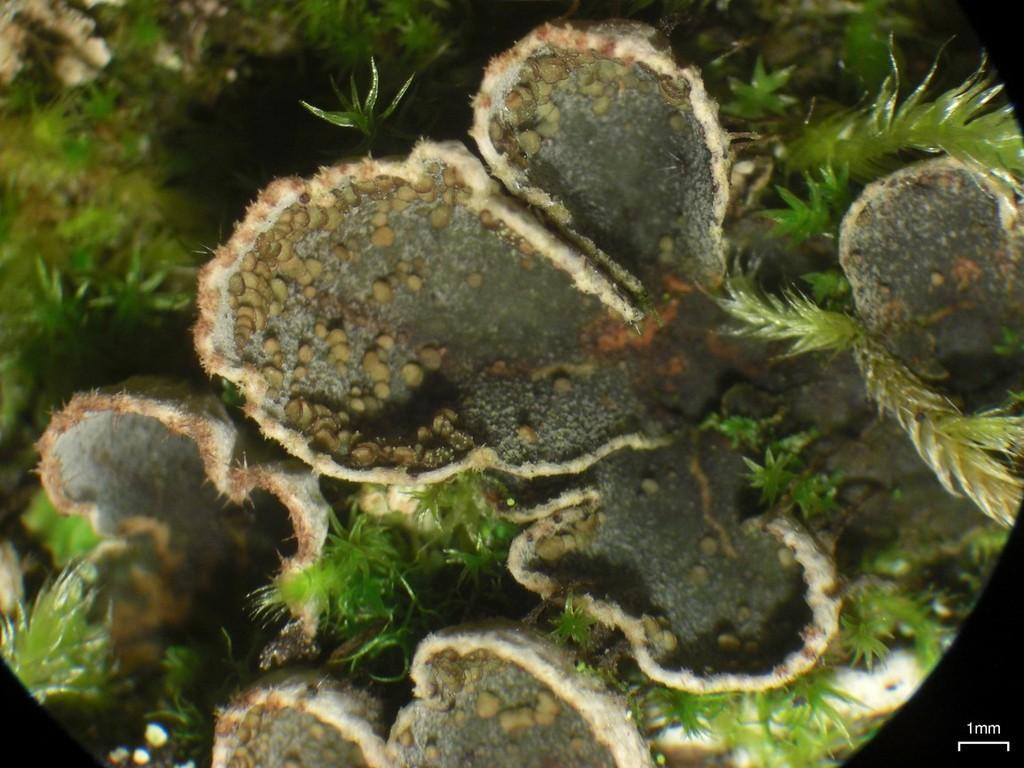What is present in the image? There is a plant in the image. What color are the leaves of the plant? The leaves of the plant are green. Can you see any pears growing on the plant in the image? There is no mention of pears or any fruit in the image; it only features a plant with green leaves. 